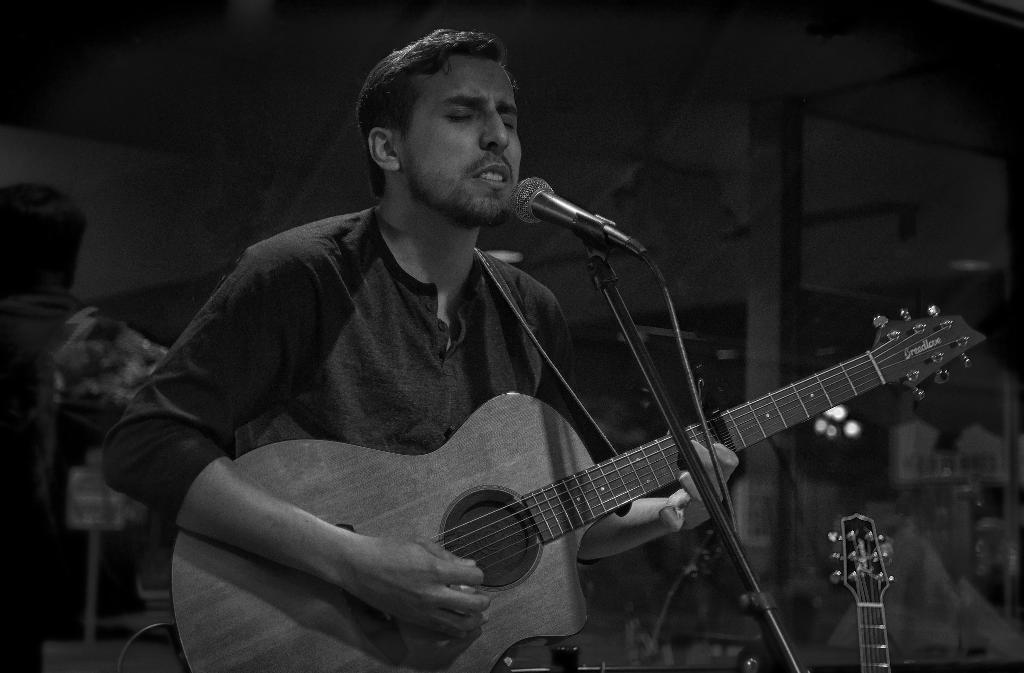What is the main subject of the picture? There is a person in the picture. What is the person holding in the picture? The person is holding a guitar. What activity is the person engaged in? The person appears to be singing a song. What is the color scheme of the picture? The picture is black and white. What type of note is the person holding in the picture? There is no note present in the picture; the person is holding a guitar. How many pets can be seen in the picture? There are no pets visible in the picture; it features a person holding a guitar and singing a song. 